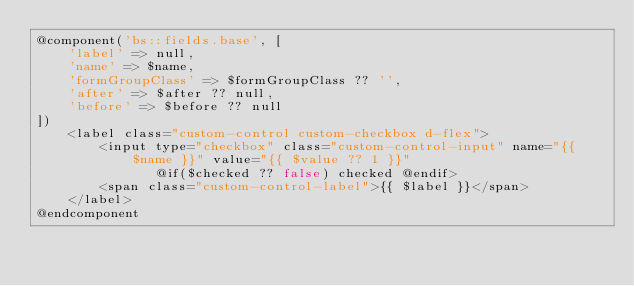<code> <loc_0><loc_0><loc_500><loc_500><_PHP_>@component('bs::fields.base', [
    'label' => null,
    'name' => $name,
    'formGroupClass' => $formGroupClass ?? '',
    'after' => $after ?? null,
    'before' => $before ?? null
])
    <label class="custom-control custom-checkbox d-flex">
        <input type="checkbox" class="custom-control-input" name="{{ $name }}" value="{{ $value ?? 1 }}" 
               @if($checked ?? false) checked @endif>
        <span class="custom-control-label">{{ $label }}</span>
    </label>
@endcomponent
</code> 